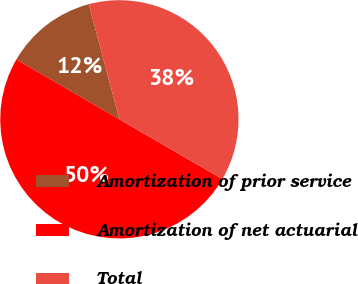<chart> <loc_0><loc_0><loc_500><loc_500><pie_chart><fcel>Amortization of prior service<fcel>Amortization of net actuarial<fcel>Total<nl><fcel>12.5%<fcel>50.0%<fcel>37.5%<nl></chart> 